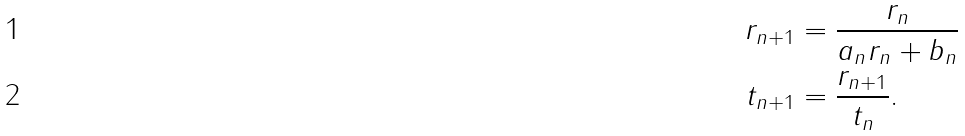<formula> <loc_0><loc_0><loc_500><loc_500>r _ { n + 1 } & = \frac { r _ { n } } { a _ { n } r _ { n } + b _ { n } } \\ t _ { n + 1 } & = \frac { r _ { n + 1 } } { t _ { n } } .</formula> 